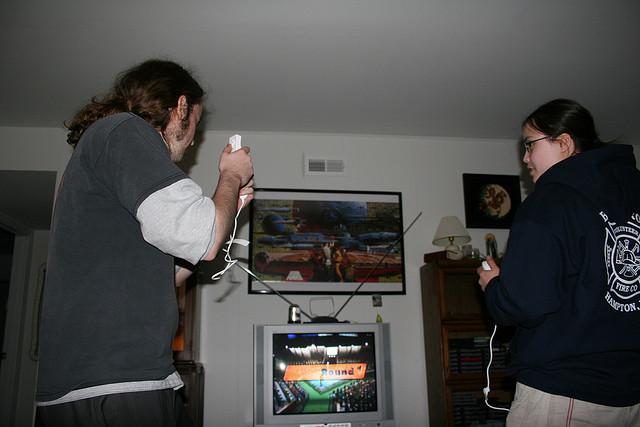How many people have glasses?
Give a very brief answer. 1. How many tvs are there?
Give a very brief answer. 2. How many people are visible?
Give a very brief answer. 2. 